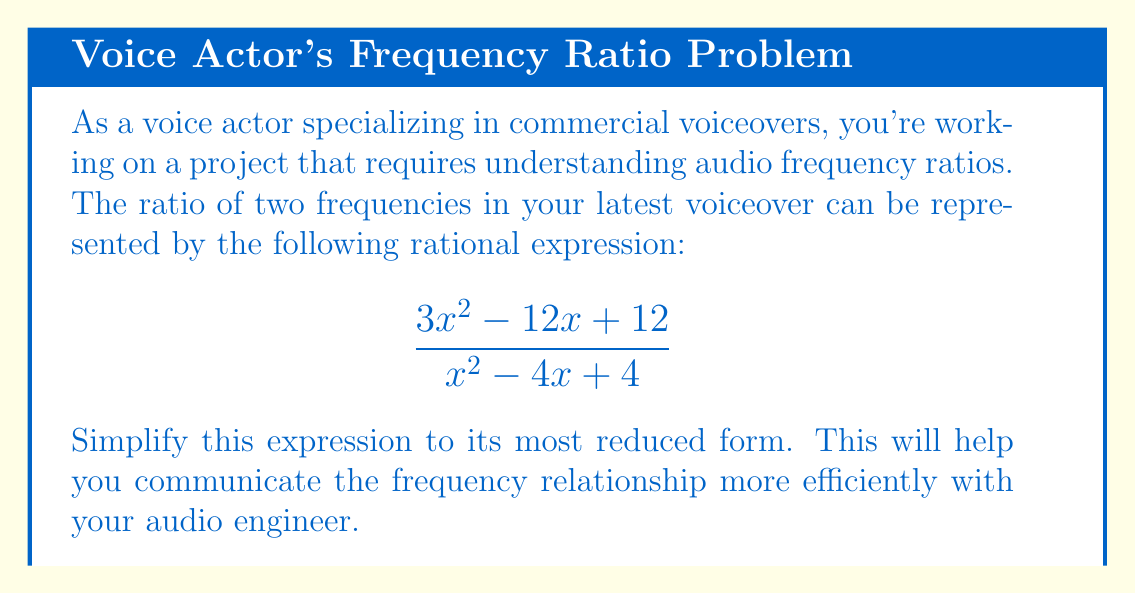Help me with this question. Let's simplify this rational expression step-by-step:

1) First, let's factor both the numerator and denominator:

   Numerator: $3x^2 - 12x + 12 = 3(x^2 - 4x + 4)$
   Denominator: $x^2 - 4x + 4 = (x - 2)^2$

2) Now our expression looks like this:

   $$\frac{3(x^2 - 4x + 4)}{(x - 2)^2}$$

3) We can see that $(x^2 - 4x + 4)$ appears in both the numerator and denominator. In the denominator, it's in the form of $(x - 2)^2$.

4) We can cancel out one $(x - 2)$ from both numerator and denominator:

   $$\frac{3(x - 2)}{x - 2} = 3$$

5) The $(x - 2)$ cancels out completely, leaving us with just 3.

This simplification shows that the ratio of the two frequencies is constant and equal to 3, regardless of the value of x.
Answer: $3$ 